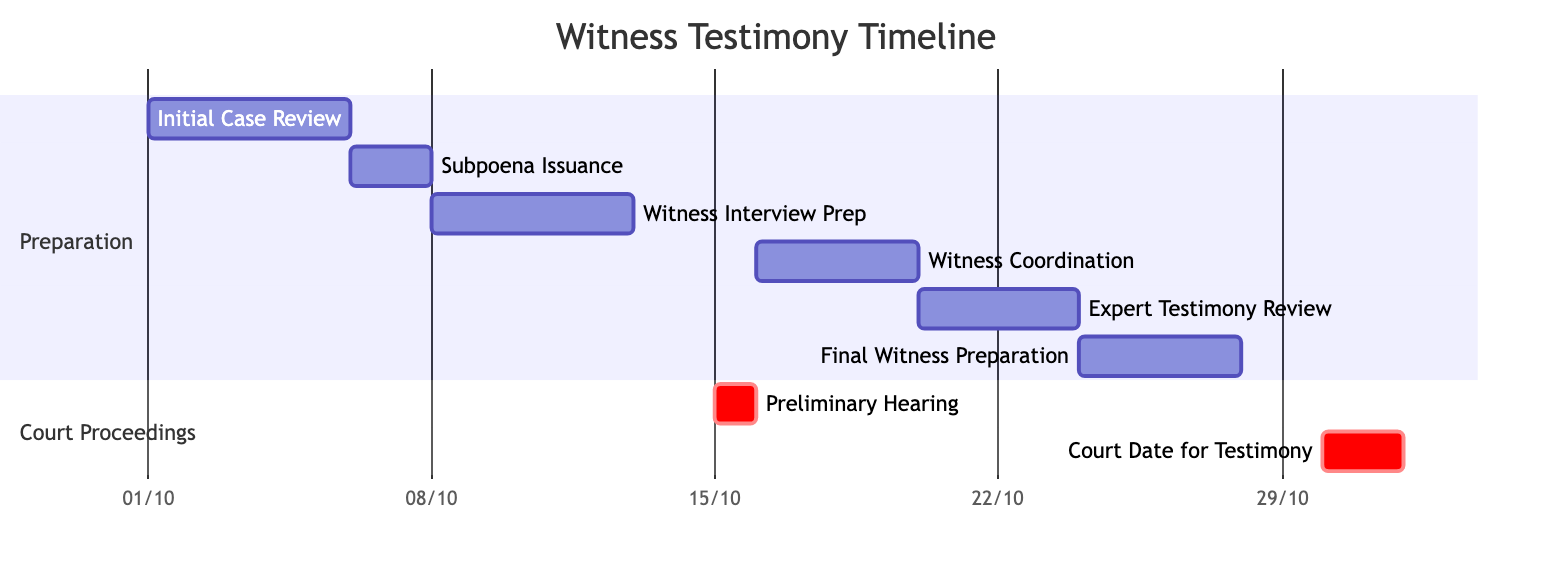What task follows the Subpoena Issuance? After the Subpoena Issuance, the next task is the Witness Interview Preparation, which begins immediately on the following day, October 8, 2023.
Answer: Witness Interview Preparation What is the duration of the Final Witness Preparation task? The Final Witness Preparation task has a duration of 4 days, starting on October 24, 2023, and ending on October 27, 2023.
Answer: 4 days Which task is scheduled immediately before the Court Date for Witness Testimony? The task scheduled immediately before the Court Date for Witness Testimony is the Final Witness Preparation, occurring from October 24 to October 27, 2023.
Answer: Final Witness Preparation How many total tasks are there in the preparation section? In the preparation section, there are a total of six tasks: Initial Case Review, Subpoena Issuance, Witness Interview Preparation, Witness Coordination, Expert Testimony Review, and Final Witness Preparation.
Answer: 6 What is the date of the Preliminary Hearing? The date of the Preliminary Hearing is October 15, 2023.
Answer: October 15, 2023 How many days are there between the Preliminary Hearing and the Court Date for Witness Testimony? The Preliminary Hearing takes place on October 15, 2023, and the Court Date for Witness Testimony begins on October 30, 2023. This results in a span of 15 days between the two events.
Answer: 15 days What is the total duration from the start of Initial Case Review to the end of Court Date for Witness Testimony? The Initial Case Review starts on October 1, 2023, and the Court Date for Witness Testimony ends on October 31, 2023. Therefore, the total duration is 30 days.
Answer: 30 days Which task overlaps with the Witness Coordination task? The Expert Testimony Review task overlaps with the Witness Coordination task as they both occur during the same time period, from October 20 to October 23, 2023.
Answer: Expert Testimony Review 